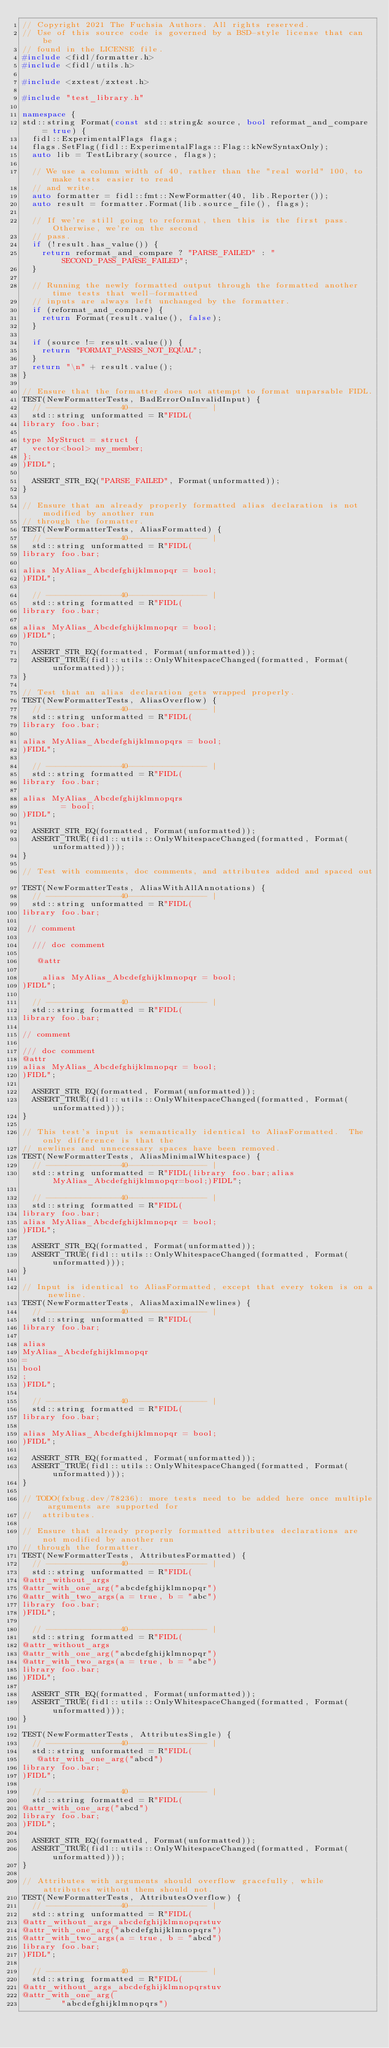Convert code to text. <code><loc_0><loc_0><loc_500><loc_500><_C++_>// Copyright 2021 The Fuchsia Authors. All rights reserved.
// Use of this source code is governed by a BSD-style license that can be
// found in the LICENSE file.
#include <fidl/formatter.h>
#include <fidl/utils.h>

#include <zxtest/zxtest.h>

#include "test_library.h"

namespace {
std::string Format(const std::string& source, bool reformat_and_compare = true) {
  fidl::ExperimentalFlags flags;
  flags.SetFlag(fidl::ExperimentalFlags::Flag::kNewSyntaxOnly);
  auto lib = TestLibrary(source, flags);

  // We use a column width of 40, rather than the "real world" 100, to make tests easier to read
  // and write.
  auto formatter = fidl::fmt::NewFormatter(40, lib.Reporter());
  auto result = formatter.Format(lib.source_file(), flags);

  // If we're still going to reformat, then this is the first pass.  Otherwise, we're on the second
  // pass.
  if (!result.has_value()) {
    return reformat_and_compare ? "PARSE_FAILED" : "SECOND_PASS_PARSE_FAILED";
  }

  // Running the newly formatted output through the formatted another time tests that well-formatted
  // inputs are always left unchanged by the formatter.
  if (reformat_and_compare) {
    return Format(result.value(), false);
  }

  if (source != result.value()) {
    return "FORMAT_PASSES_NOT_EQUAL";
  }
  return "\n" + result.value();
}

// Ensure that the formatter does not attempt to format unparsable FIDL.
TEST(NewFormatterTests, BadErrorOnInvalidInput) {
  // ---------------40---------------- |
  std::string unformatted = R"FIDL(
library foo.bar;

type MyStruct = struct {
  vector<bool> my_member;
};
)FIDL";

  ASSERT_STR_EQ("PARSE_FAILED", Format(unformatted));
}

// Ensure that an already properly formatted alias declaration is not modified by another run
// through the formatter.
TEST(NewFormatterTests, AliasFormatted) {
  // ---------------40---------------- |
  std::string unformatted = R"FIDL(
library foo.bar;

alias MyAlias_Abcdefghijklmnopqr = bool;
)FIDL";

  // ---------------40---------------- |
  std::string formatted = R"FIDL(
library foo.bar;

alias MyAlias_Abcdefghijklmnopqr = bool;
)FIDL";

  ASSERT_STR_EQ(formatted, Format(unformatted));
  ASSERT_TRUE(fidl::utils::OnlyWhitespaceChanged(formatted, Format(unformatted)));
}

// Test that an alias declaration gets wrapped properly.
TEST(NewFormatterTests, AliasOverflow) {
  // ---------------40---------------- |
  std::string unformatted = R"FIDL(
library foo.bar;

alias MyAlias_Abcdefghijklmnopqrs = bool;
)FIDL";

  // ---------------40---------------- |
  std::string formatted = R"FIDL(
library foo.bar;

alias MyAlias_Abcdefghijklmnopqrs
        = bool;
)FIDL";

  ASSERT_STR_EQ(formatted, Format(unformatted));
  ASSERT_TRUE(fidl::utils::OnlyWhitespaceChanged(formatted, Format(unformatted)));
}

// Test with comments, doc comments, and attributes added and spaced out.
TEST(NewFormatterTests, AliasWithAllAnnotations) {
  // ---------------40---------------- |
  std::string unformatted = R"FIDL(
library foo.bar;

 // comment

  /// doc comment

   @attr

    alias MyAlias_Abcdefghijklmnopqr = bool;
)FIDL";

  // ---------------40---------------- |
  std::string formatted = R"FIDL(
library foo.bar;

// comment

/// doc comment
@attr
alias MyAlias_Abcdefghijklmnopqr = bool;
)FIDL";

  ASSERT_STR_EQ(formatted, Format(unformatted));
  ASSERT_TRUE(fidl::utils::OnlyWhitespaceChanged(formatted, Format(unformatted)));
}

// This test's input is semantically identical to AliasFormatted.  The only difference is that the
// newlines and unnecessary spaces have been removed.
TEST(NewFormatterTests, AliasMinimalWhitespace) {
  // ---------------40---------------- |
  std::string unformatted = R"FIDL(library foo.bar;alias MyAlias_Abcdefghijklmnopqr=bool;)FIDL";

  // ---------------40---------------- |
  std::string formatted = R"FIDL(
library foo.bar;
alias MyAlias_Abcdefghijklmnopqr = bool;
)FIDL";

  ASSERT_STR_EQ(formatted, Format(unformatted));
  ASSERT_TRUE(fidl::utils::OnlyWhitespaceChanged(formatted, Format(unformatted)));
}

// Input is identical to AliasFormatted, except that every token is on a newline.
TEST(NewFormatterTests, AliasMaximalNewlines) {
  // ---------------40---------------- |
  std::string unformatted = R"FIDL(
library foo.bar;

alias
MyAlias_Abcdefghijklmnopqr
=
bool
;
)FIDL";

  // ---------------40---------------- |
  std::string formatted = R"FIDL(
library foo.bar;

alias MyAlias_Abcdefghijklmnopqr = bool;
)FIDL";

  ASSERT_STR_EQ(formatted, Format(unformatted));
  ASSERT_TRUE(fidl::utils::OnlyWhitespaceChanged(formatted, Format(unformatted)));
}

// TODO(fxbug.dev/78236): more tests need to be added here once multiple arguments are supported for
//  attributes.

// Ensure that already properly formatted attributes declarations are not modified by another run
// through the formatter.
TEST(NewFormatterTests, AttributesFormatted) {
  // ---------------40---------------- |
  std::string unformatted = R"FIDL(
@attr_without_args
@attr_with_one_arg("abcdefghijklmnopqr")
@attr_with_two_args(a = true, b = "abc")
library foo.bar;
)FIDL";

  // ---------------40---------------- |
  std::string formatted = R"FIDL(
@attr_without_args
@attr_with_one_arg("abcdefghijklmnopqr")
@attr_with_two_args(a = true, b = "abc")
library foo.bar;
)FIDL";

  ASSERT_STR_EQ(formatted, Format(unformatted));
  ASSERT_TRUE(fidl::utils::OnlyWhitespaceChanged(formatted, Format(unformatted)));
}

TEST(NewFormatterTests, AttributesSingle) {
  // ---------------40---------------- |
  std::string unformatted = R"FIDL(
   @attr_with_one_arg("abcd")
library foo.bar;
)FIDL";

  // ---------------40---------------- |
  std::string formatted = R"FIDL(
@attr_with_one_arg("abcd")
library foo.bar;
)FIDL";

  ASSERT_STR_EQ(formatted, Format(unformatted));
  ASSERT_TRUE(fidl::utils::OnlyWhitespaceChanged(formatted, Format(unformatted)));
}

// Attributes with arguments should overflow gracefully, while attributes without them should not.
TEST(NewFormatterTests, AttributesOverflow) {
  // ---------------40---------------- |
  std::string unformatted = R"FIDL(
@attr_without_args_abcdefghijklmnopqrstuv
@attr_with_one_arg("abcdefghijklmnopqrs")
@attr_with_two_args(a = true, b = "abcd")
library foo.bar;
)FIDL";

  // ---------------40---------------- |
  std::string formatted = R"FIDL(
@attr_without_args_abcdefghijklmnopqrstuv
@attr_with_one_arg(
        "abcdefghijklmnopqrs")</code> 